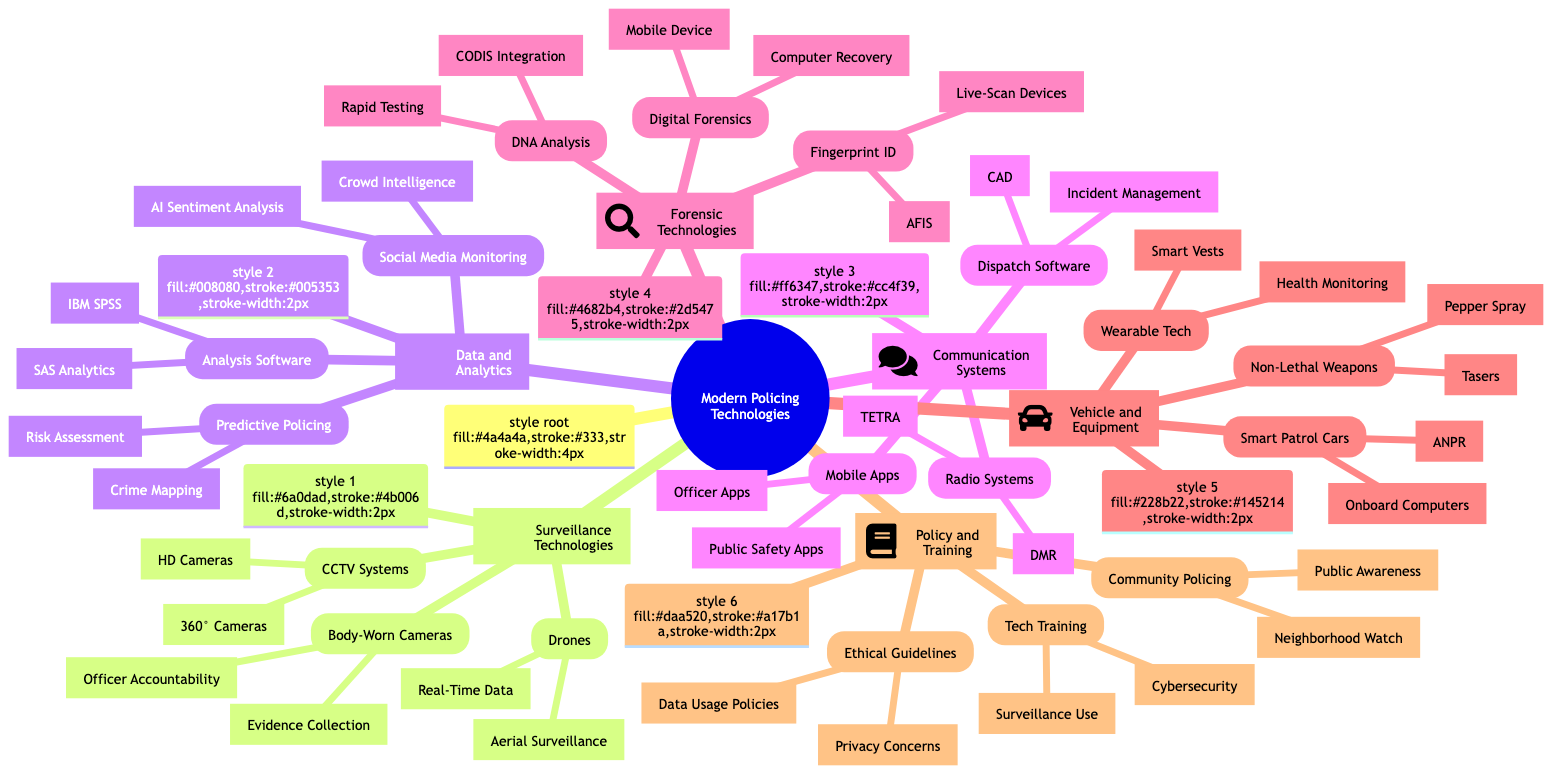What are the components under Surveillance Technologies? The "Surveillance Technologies" node branches into three main components: "CCTV Systems," "Drones," and "Body-Worn Cameras." Each of these has specific technologies listed beneath them.
Answer: CCTV Systems, Drones, Body-Worn Cameras How many types of Communication Systems are there? The "Communication Systems" node has three types listed beneath it: "Radio Systems," "Dispatch Software," and "Mobile Apps." Therefore, there are a total of three types.
Answer: 3 What technology is used for officer accountability? Under "Body-Worn Cameras," the specific technology mentioned for officer accountability is "Officer Accountability." This directly associates with how body-worn cameras are utilized in this context.
Answer: Officer Accountability Which data analysis software is listed? The "Data Analysis Software" node includes two specific tools: "IBM SPSS" and "SAS Analytics." Either of these can be the answer, but for clarity, "IBM SPSS" is a direct mention.
Answer: IBM SPSS Which technology category has non-lethal weapons? The "Vehicle and Equipment Integration" section includes "Non-Lethal Weapons," which comprises technologies like "Tasers" and "Pepper Spray." This categorization indicates the focus on equipment rather than direct weaponry.
Answer: Non-Lethal Weapons What is the primary focus of Policy and Training? The "Policy and Training" node branches out into "Technology Training Programs," "Ethical Guidelines," and "Community Policing Strategies," indicating a focus on improving practices through policy and community engagement.
Answer: Policy and Training How does Predictive Policing utilize crime mapping? The "Predictive Policing" under "Data and Analytics" includes "Crime Mapping," which utilizes various data points to analyze and predict where crimes may occur, aiding in resource allocation and proactive command.
Answer: Crime Mapping What is a characteristic of Smart Patrol Cars? "Smart Patrol Cars" are equipped with "Onboard Computers" and "Automatic Number Plate Recognition (ANPR)," both of which look to enhance patrol efficiency and data access while on duty.
Answer: Onboard Computers What ethical concern is highlighted in Ethical Guidelines? The "Ethical Guidelines" under "Policy and Training" point towards "Privacy Concerns," indicating the need to address issues surrounding the collection and use of data in policing technologies.
Answer: Privacy Concerns 